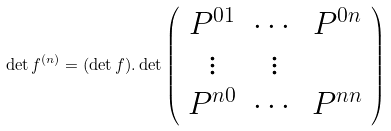<formula> <loc_0><loc_0><loc_500><loc_500>\det f ^ { ( n ) } = ( \det f ) . \det \left ( \begin{array} { c c c } P ^ { 0 1 } & \cdots & P ^ { 0 n } \\ \vdots & \vdots \\ P ^ { n 0 } & \cdots & P ^ { n n } \end{array} \right )</formula> 